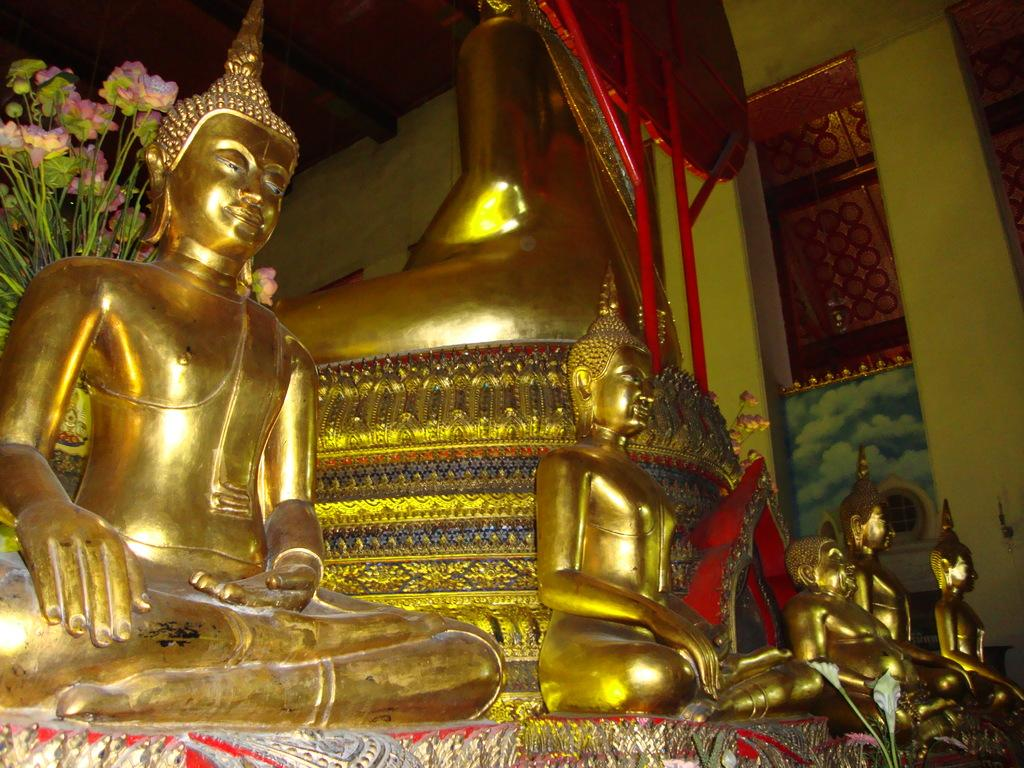What type of sculptures can be seen in the image? There are sculptures of Buddha in the image. What is the color of the sculptures? The sculptures are gold in color. What can be found on the right side of the image? There are objects on the right side of the image. What type of vegetation or decoration is on the left side of the image? There are flowers on the left side of the image. What type of jar is being used by the sculpture of Buddha in the image? There is no jar present in the image; the sculptures of Buddha are gold in color and do not have any objects in their hands or around them. 